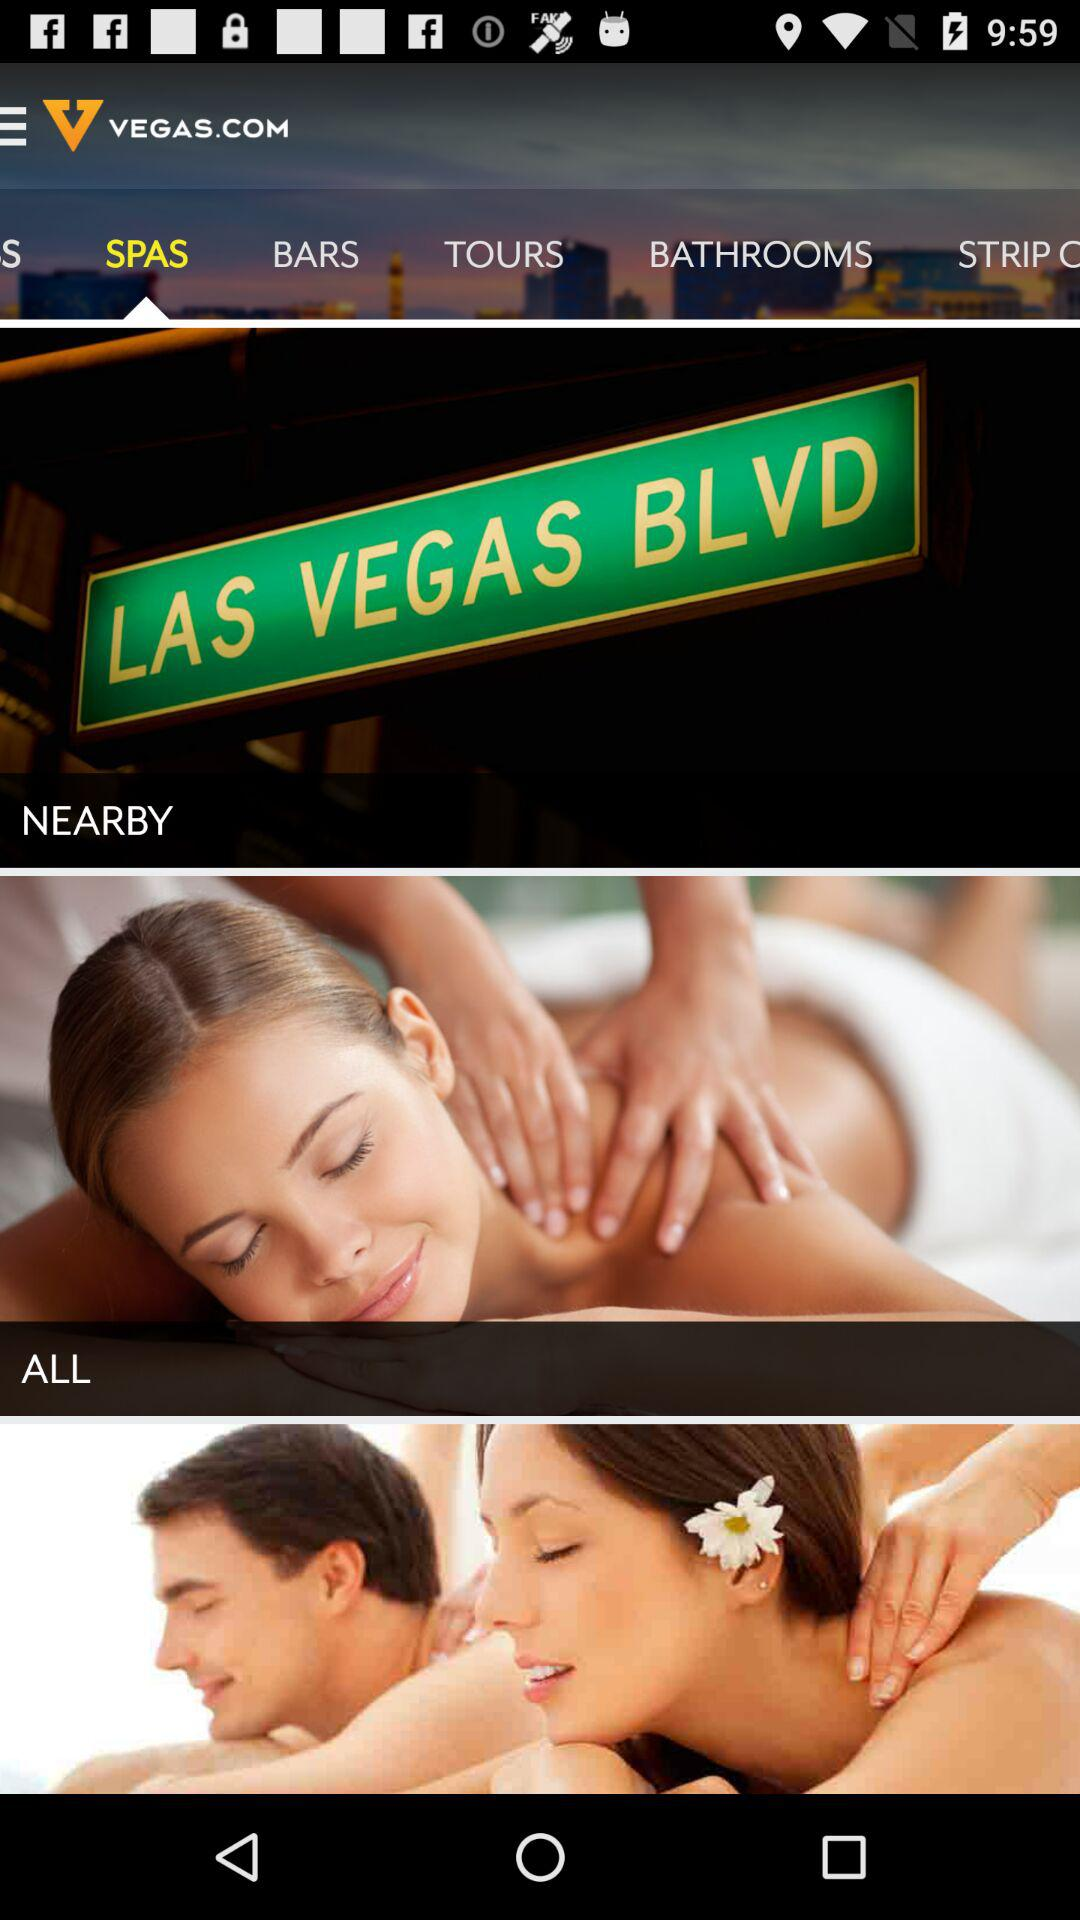Which tab is selected? The selected tab is "SPAS". 